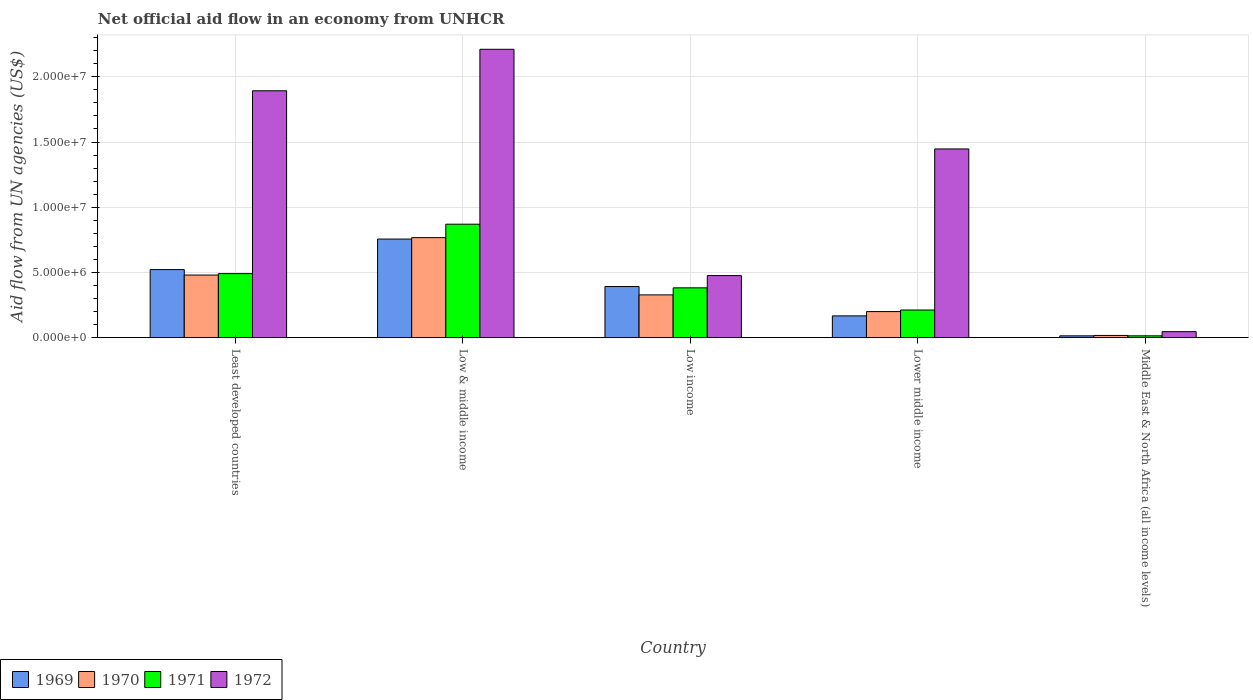How many different coloured bars are there?
Offer a terse response. 4. How many groups of bars are there?
Your answer should be compact. 5. Are the number of bars on each tick of the X-axis equal?
Keep it short and to the point. Yes. What is the label of the 4th group of bars from the left?
Your answer should be compact. Lower middle income. What is the net official aid flow in 1969 in Least developed countries?
Your answer should be very brief. 5.22e+06. Across all countries, what is the maximum net official aid flow in 1970?
Offer a terse response. 7.67e+06. Across all countries, what is the minimum net official aid flow in 1969?
Provide a succinct answer. 1.40e+05. In which country was the net official aid flow in 1972 minimum?
Your answer should be compact. Middle East & North Africa (all income levels). What is the total net official aid flow in 1970 in the graph?
Provide a short and direct response. 1.79e+07. What is the difference between the net official aid flow in 1972 in Least developed countries and that in Low & middle income?
Offer a terse response. -3.18e+06. What is the difference between the net official aid flow in 1972 in Low & middle income and the net official aid flow in 1970 in Low income?
Your answer should be compact. 1.88e+07. What is the average net official aid flow in 1972 per country?
Provide a short and direct response. 1.21e+07. What is the difference between the net official aid flow of/in 1972 and net official aid flow of/in 1971 in Low & middle income?
Make the answer very short. 1.34e+07. What is the ratio of the net official aid flow in 1971 in Least developed countries to that in Low income?
Your answer should be compact. 1.29. What is the difference between the highest and the second highest net official aid flow in 1971?
Your answer should be very brief. 4.88e+06. What is the difference between the highest and the lowest net official aid flow in 1972?
Offer a terse response. 2.16e+07. Is the sum of the net official aid flow in 1971 in Low income and Lower middle income greater than the maximum net official aid flow in 1969 across all countries?
Your answer should be very brief. No. Is it the case that in every country, the sum of the net official aid flow in 1970 and net official aid flow in 1971 is greater than the sum of net official aid flow in 1969 and net official aid flow in 1972?
Offer a very short reply. No. What does the 1st bar from the left in Least developed countries represents?
Offer a very short reply. 1969. How many bars are there?
Offer a very short reply. 20. Are all the bars in the graph horizontal?
Offer a very short reply. No. What is the difference between two consecutive major ticks on the Y-axis?
Give a very brief answer. 5.00e+06. Are the values on the major ticks of Y-axis written in scientific E-notation?
Your answer should be compact. Yes. Does the graph contain grids?
Your answer should be very brief. Yes. How are the legend labels stacked?
Make the answer very short. Horizontal. What is the title of the graph?
Make the answer very short. Net official aid flow in an economy from UNHCR. What is the label or title of the Y-axis?
Provide a short and direct response. Aid flow from UN agencies (US$). What is the Aid flow from UN agencies (US$) in 1969 in Least developed countries?
Provide a short and direct response. 5.22e+06. What is the Aid flow from UN agencies (US$) of 1970 in Least developed countries?
Provide a short and direct response. 4.80e+06. What is the Aid flow from UN agencies (US$) of 1971 in Least developed countries?
Provide a short and direct response. 4.91e+06. What is the Aid flow from UN agencies (US$) of 1972 in Least developed countries?
Provide a short and direct response. 1.89e+07. What is the Aid flow from UN agencies (US$) in 1969 in Low & middle income?
Offer a very short reply. 7.56e+06. What is the Aid flow from UN agencies (US$) of 1970 in Low & middle income?
Provide a short and direct response. 7.67e+06. What is the Aid flow from UN agencies (US$) in 1971 in Low & middle income?
Provide a short and direct response. 8.70e+06. What is the Aid flow from UN agencies (US$) in 1972 in Low & middle income?
Offer a very short reply. 2.21e+07. What is the Aid flow from UN agencies (US$) in 1969 in Low income?
Provide a short and direct response. 3.92e+06. What is the Aid flow from UN agencies (US$) of 1970 in Low income?
Ensure brevity in your answer.  3.28e+06. What is the Aid flow from UN agencies (US$) in 1971 in Low income?
Provide a short and direct response. 3.82e+06. What is the Aid flow from UN agencies (US$) of 1972 in Low income?
Provide a short and direct response. 4.76e+06. What is the Aid flow from UN agencies (US$) of 1969 in Lower middle income?
Give a very brief answer. 1.67e+06. What is the Aid flow from UN agencies (US$) of 1970 in Lower middle income?
Ensure brevity in your answer.  2.00e+06. What is the Aid flow from UN agencies (US$) of 1971 in Lower middle income?
Provide a short and direct response. 2.12e+06. What is the Aid flow from UN agencies (US$) of 1972 in Lower middle income?
Offer a terse response. 1.45e+07. What is the Aid flow from UN agencies (US$) in 1969 in Middle East & North Africa (all income levels)?
Your answer should be compact. 1.40e+05. Across all countries, what is the maximum Aid flow from UN agencies (US$) of 1969?
Your answer should be compact. 7.56e+06. Across all countries, what is the maximum Aid flow from UN agencies (US$) in 1970?
Your answer should be very brief. 7.67e+06. Across all countries, what is the maximum Aid flow from UN agencies (US$) in 1971?
Make the answer very short. 8.70e+06. Across all countries, what is the maximum Aid flow from UN agencies (US$) of 1972?
Your answer should be very brief. 2.21e+07. Across all countries, what is the minimum Aid flow from UN agencies (US$) in 1969?
Offer a very short reply. 1.40e+05. Across all countries, what is the minimum Aid flow from UN agencies (US$) in 1970?
Your answer should be very brief. 1.70e+05. Across all countries, what is the minimum Aid flow from UN agencies (US$) of 1972?
Offer a terse response. 4.60e+05. What is the total Aid flow from UN agencies (US$) in 1969 in the graph?
Ensure brevity in your answer.  1.85e+07. What is the total Aid flow from UN agencies (US$) in 1970 in the graph?
Offer a terse response. 1.79e+07. What is the total Aid flow from UN agencies (US$) of 1971 in the graph?
Your response must be concise. 1.97e+07. What is the total Aid flow from UN agencies (US$) in 1972 in the graph?
Keep it short and to the point. 6.07e+07. What is the difference between the Aid flow from UN agencies (US$) of 1969 in Least developed countries and that in Low & middle income?
Provide a succinct answer. -2.34e+06. What is the difference between the Aid flow from UN agencies (US$) in 1970 in Least developed countries and that in Low & middle income?
Your answer should be very brief. -2.87e+06. What is the difference between the Aid flow from UN agencies (US$) in 1971 in Least developed countries and that in Low & middle income?
Provide a short and direct response. -3.79e+06. What is the difference between the Aid flow from UN agencies (US$) in 1972 in Least developed countries and that in Low & middle income?
Your answer should be compact. -3.18e+06. What is the difference between the Aid flow from UN agencies (US$) in 1969 in Least developed countries and that in Low income?
Offer a very short reply. 1.30e+06. What is the difference between the Aid flow from UN agencies (US$) of 1970 in Least developed countries and that in Low income?
Keep it short and to the point. 1.52e+06. What is the difference between the Aid flow from UN agencies (US$) in 1971 in Least developed countries and that in Low income?
Make the answer very short. 1.09e+06. What is the difference between the Aid flow from UN agencies (US$) of 1972 in Least developed countries and that in Low income?
Provide a succinct answer. 1.42e+07. What is the difference between the Aid flow from UN agencies (US$) in 1969 in Least developed countries and that in Lower middle income?
Your answer should be compact. 3.55e+06. What is the difference between the Aid flow from UN agencies (US$) of 1970 in Least developed countries and that in Lower middle income?
Keep it short and to the point. 2.80e+06. What is the difference between the Aid flow from UN agencies (US$) in 1971 in Least developed countries and that in Lower middle income?
Keep it short and to the point. 2.79e+06. What is the difference between the Aid flow from UN agencies (US$) of 1972 in Least developed countries and that in Lower middle income?
Provide a short and direct response. 4.46e+06. What is the difference between the Aid flow from UN agencies (US$) of 1969 in Least developed countries and that in Middle East & North Africa (all income levels)?
Your answer should be compact. 5.08e+06. What is the difference between the Aid flow from UN agencies (US$) in 1970 in Least developed countries and that in Middle East & North Africa (all income levels)?
Make the answer very short. 4.63e+06. What is the difference between the Aid flow from UN agencies (US$) in 1971 in Least developed countries and that in Middle East & North Africa (all income levels)?
Provide a short and direct response. 4.77e+06. What is the difference between the Aid flow from UN agencies (US$) in 1972 in Least developed countries and that in Middle East & North Africa (all income levels)?
Keep it short and to the point. 1.85e+07. What is the difference between the Aid flow from UN agencies (US$) of 1969 in Low & middle income and that in Low income?
Offer a terse response. 3.64e+06. What is the difference between the Aid flow from UN agencies (US$) in 1970 in Low & middle income and that in Low income?
Make the answer very short. 4.39e+06. What is the difference between the Aid flow from UN agencies (US$) of 1971 in Low & middle income and that in Low income?
Offer a very short reply. 4.88e+06. What is the difference between the Aid flow from UN agencies (US$) of 1972 in Low & middle income and that in Low income?
Make the answer very short. 1.74e+07. What is the difference between the Aid flow from UN agencies (US$) in 1969 in Low & middle income and that in Lower middle income?
Provide a succinct answer. 5.89e+06. What is the difference between the Aid flow from UN agencies (US$) of 1970 in Low & middle income and that in Lower middle income?
Provide a succinct answer. 5.67e+06. What is the difference between the Aid flow from UN agencies (US$) in 1971 in Low & middle income and that in Lower middle income?
Provide a short and direct response. 6.58e+06. What is the difference between the Aid flow from UN agencies (US$) of 1972 in Low & middle income and that in Lower middle income?
Your answer should be compact. 7.64e+06. What is the difference between the Aid flow from UN agencies (US$) of 1969 in Low & middle income and that in Middle East & North Africa (all income levels)?
Your response must be concise. 7.42e+06. What is the difference between the Aid flow from UN agencies (US$) in 1970 in Low & middle income and that in Middle East & North Africa (all income levels)?
Offer a terse response. 7.50e+06. What is the difference between the Aid flow from UN agencies (US$) in 1971 in Low & middle income and that in Middle East & North Africa (all income levels)?
Give a very brief answer. 8.56e+06. What is the difference between the Aid flow from UN agencies (US$) in 1972 in Low & middle income and that in Middle East & North Africa (all income levels)?
Offer a very short reply. 2.16e+07. What is the difference between the Aid flow from UN agencies (US$) in 1969 in Low income and that in Lower middle income?
Provide a short and direct response. 2.25e+06. What is the difference between the Aid flow from UN agencies (US$) in 1970 in Low income and that in Lower middle income?
Ensure brevity in your answer.  1.28e+06. What is the difference between the Aid flow from UN agencies (US$) of 1971 in Low income and that in Lower middle income?
Provide a short and direct response. 1.70e+06. What is the difference between the Aid flow from UN agencies (US$) of 1972 in Low income and that in Lower middle income?
Your answer should be compact. -9.71e+06. What is the difference between the Aid flow from UN agencies (US$) of 1969 in Low income and that in Middle East & North Africa (all income levels)?
Provide a short and direct response. 3.78e+06. What is the difference between the Aid flow from UN agencies (US$) in 1970 in Low income and that in Middle East & North Africa (all income levels)?
Offer a terse response. 3.11e+06. What is the difference between the Aid flow from UN agencies (US$) in 1971 in Low income and that in Middle East & North Africa (all income levels)?
Keep it short and to the point. 3.68e+06. What is the difference between the Aid flow from UN agencies (US$) in 1972 in Low income and that in Middle East & North Africa (all income levels)?
Ensure brevity in your answer.  4.30e+06. What is the difference between the Aid flow from UN agencies (US$) of 1969 in Lower middle income and that in Middle East & North Africa (all income levels)?
Your answer should be very brief. 1.53e+06. What is the difference between the Aid flow from UN agencies (US$) in 1970 in Lower middle income and that in Middle East & North Africa (all income levels)?
Provide a short and direct response. 1.83e+06. What is the difference between the Aid flow from UN agencies (US$) of 1971 in Lower middle income and that in Middle East & North Africa (all income levels)?
Provide a short and direct response. 1.98e+06. What is the difference between the Aid flow from UN agencies (US$) in 1972 in Lower middle income and that in Middle East & North Africa (all income levels)?
Your answer should be very brief. 1.40e+07. What is the difference between the Aid flow from UN agencies (US$) of 1969 in Least developed countries and the Aid flow from UN agencies (US$) of 1970 in Low & middle income?
Ensure brevity in your answer.  -2.45e+06. What is the difference between the Aid flow from UN agencies (US$) in 1969 in Least developed countries and the Aid flow from UN agencies (US$) in 1971 in Low & middle income?
Ensure brevity in your answer.  -3.48e+06. What is the difference between the Aid flow from UN agencies (US$) in 1969 in Least developed countries and the Aid flow from UN agencies (US$) in 1972 in Low & middle income?
Provide a succinct answer. -1.69e+07. What is the difference between the Aid flow from UN agencies (US$) of 1970 in Least developed countries and the Aid flow from UN agencies (US$) of 1971 in Low & middle income?
Your answer should be very brief. -3.90e+06. What is the difference between the Aid flow from UN agencies (US$) of 1970 in Least developed countries and the Aid flow from UN agencies (US$) of 1972 in Low & middle income?
Ensure brevity in your answer.  -1.73e+07. What is the difference between the Aid flow from UN agencies (US$) of 1971 in Least developed countries and the Aid flow from UN agencies (US$) of 1972 in Low & middle income?
Your answer should be compact. -1.72e+07. What is the difference between the Aid flow from UN agencies (US$) in 1969 in Least developed countries and the Aid flow from UN agencies (US$) in 1970 in Low income?
Provide a short and direct response. 1.94e+06. What is the difference between the Aid flow from UN agencies (US$) in 1969 in Least developed countries and the Aid flow from UN agencies (US$) in 1971 in Low income?
Offer a very short reply. 1.40e+06. What is the difference between the Aid flow from UN agencies (US$) of 1970 in Least developed countries and the Aid flow from UN agencies (US$) of 1971 in Low income?
Give a very brief answer. 9.80e+05. What is the difference between the Aid flow from UN agencies (US$) of 1970 in Least developed countries and the Aid flow from UN agencies (US$) of 1972 in Low income?
Your answer should be very brief. 4.00e+04. What is the difference between the Aid flow from UN agencies (US$) of 1971 in Least developed countries and the Aid flow from UN agencies (US$) of 1972 in Low income?
Give a very brief answer. 1.50e+05. What is the difference between the Aid flow from UN agencies (US$) of 1969 in Least developed countries and the Aid flow from UN agencies (US$) of 1970 in Lower middle income?
Your answer should be compact. 3.22e+06. What is the difference between the Aid flow from UN agencies (US$) of 1969 in Least developed countries and the Aid flow from UN agencies (US$) of 1971 in Lower middle income?
Provide a short and direct response. 3.10e+06. What is the difference between the Aid flow from UN agencies (US$) of 1969 in Least developed countries and the Aid flow from UN agencies (US$) of 1972 in Lower middle income?
Provide a short and direct response. -9.25e+06. What is the difference between the Aid flow from UN agencies (US$) in 1970 in Least developed countries and the Aid flow from UN agencies (US$) in 1971 in Lower middle income?
Your answer should be very brief. 2.68e+06. What is the difference between the Aid flow from UN agencies (US$) of 1970 in Least developed countries and the Aid flow from UN agencies (US$) of 1972 in Lower middle income?
Your answer should be compact. -9.67e+06. What is the difference between the Aid flow from UN agencies (US$) in 1971 in Least developed countries and the Aid flow from UN agencies (US$) in 1972 in Lower middle income?
Your answer should be very brief. -9.56e+06. What is the difference between the Aid flow from UN agencies (US$) of 1969 in Least developed countries and the Aid flow from UN agencies (US$) of 1970 in Middle East & North Africa (all income levels)?
Offer a terse response. 5.05e+06. What is the difference between the Aid flow from UN agencies (US$) of 1969 in Least developed countries and the Aid flow from UN agencies (US$) of 1971 in Middle East & North Africa (all income levels)?
Keep it short and to the point. 5.08e+06. What is the difference between the Aid flow from UN agencies (US$) of 1969 in Least developed countries and the Aid flow from UN agencies (US$) of 1972 in Middle East & North Africa (all income levels)?
Your response must be concise. 4.76e+06. What is the difference between the Aid flow from UN agencies (US$) of 1970 in Least developed countries and the Aid flow from UN agencies (US$) of 1971 in Middle East & North Africa (all income levels)?
Keep it short and to the point. 4.66e+06. What is the difference between the Aid flow from UN agencies (US$) in 1970 in Least developed countries and the Aid flow from UN agencies (US$) in 1972 in Middle East & North Africa (all income levels)?
Your response must be concise. 4.34e+06. What is the difference between the Aid flow from UN agencies (US$) in 1971 in Least developed countries and the Aid flow from UN agencies (US$) in 1972 in Middle East & North Africa (all income levels)?
Your answer should be very brief. 4.45e+06. What is the difference between the Aid flow from UN agencies (US$) in 1969 in Low & middle income and the Aid flow from UN agencies (US$) in 1970 in Low income?
Your answer should be very brief. 4.28e+06. What is the difference between the Aid flow from UN agencies (US$) in 1969 in Low & middle income and the Aid flow from UN agencies (US$) in 1971 in Low income?
Keep it short and to the point. 3.74e+06. What is the difference between the Aid flow from UN agencies (US$) in 1969 in Low & middle income and the Aid flow from UN agencies (US$) in 1972 in Low income?
Keep it short and to the point. 2.80e+06. What is the difference between the Aid flow from UN agencies (US$) of 1970 in Low & middle income and the Aid flow from UN agencies (US$) of 1971 in Low income?
Give a very brief answer. 3.85e+06. What is the difference between the Aid flow from UN agencies (US$) of 1970 in Low & middle income and the Aid flow from UN agencies (US$) of 1972 in Low income?
Your answer should be compact. 2.91e+06. What is the difference between the Aid flow from UN agencies (US$) of 1971 in Low & middle income and the Aid flow from UN agencies (US$) of 1972 in Low income?
Ensure brevity in your answer.  3.94e+06. What is the difference between the Aid flow from UN agencies (US$) of 1969 in Low & middle income and the Aid flow from UN agencies (US$) of 1970 in Lower middle income?
Your response must be concise. 5.56e+06. What is the difference between the Aid flow from UN agencies (US$) in 1969 in Low & middle income and the Aid flow from UN agencies (US$) in 1971 in Lower middle income?
Your response must be concise. 5.44e+06. What is the difference between the Aid flow from UN agencies (US$) in 1969 in Low & middle income and the Aid flow from UN agencies (US$) in 1972 in Lower middle income?
Your answer should be very brief. -6.91e+06. What is the difference between the Aid flow from UN agencies (US$) of 1970 in Low & middle income and the Aid flow from UN agencies (US$) of 1971 in Lower middle income?
Your answer should be very brief. 5.55e+06. What is the difference between the Aid flow from UN agencies (US$) of 1970 in Low & middle income and the Aid flow from UN agencies (US$) of 1972 in Lower middle income?
Make the answer very short. -6.80e+06. What is the difference between the Aid flow from UN agencies (US$) in 1971 in Low & middle income and the Aid flow from UN agencies (US$) in 1972 in Lower middle income?
Provide a succinct answer. -5.77e+06. What is the difference between the Aid flow from UN agencies (US$) in 1969 in Low & middle income and the Aid flow from UN agencies (US$) in 1970 in Middle East & North Africa (all income levels)?
Keep it short and to the point. 7.39e+06. What is the difference between the Aid flow from UN agencies (US$) of 1969 in Low & middle income and the Aid flow from UN agencies (US$) of 1971 in Middle East & North Africa (all income levels)?
Offer a very short reply. 7.42e+06. What is the difference between the Aid flow from UN agencies (US$) in 1969 in Low & middle income and the Aid flow from UN agencies (US$) in 1972 in Middle East & North Africa (all income levels)?
Your answer should be compact. 7.10e+06. What is the difference between the Aid flow from UN agencies (US$) in 1970 in Low & middle income and the Aid flow from UN agencies (US$) in 1971 in Middle East & North Africa (all income levels)?
Keep it short and to the point. 7.53e+06. What is the difference between the Aid flow from UN agencies (US$) of 1970 in Low & middle income and the Aid flow from UN agencies (US$) of 1972 in Middle East & North Africa (all income levels)?
Provide a succinct answer. 7.21e+06. What is the difference between the Aid flow from UN agencies (US$) of 1971 in Low & middle income and the Aid flow from UN agencies (US$) of 1972 in Middle East & North Africa (all income levels)?
Your answer should be compact. 8.24e+06. What is the difference between the Aid flow from UN agencies (US$) of 1969 in Low income and the Aid flow from UN agencies (US$) of 1970 in Lower middle income?
Keep it short and to the point. 1.92e+06. What is the difference between the Aid flow from UN agencies (US$) in 1969 in Low income and the Aid flow from UN agencies (US$) in 1971 in Lower middle income?
Your answer should be very brief. 1.80e+06. What is the difference between the Aid flow from UN agencies (US$) in 1969 in Low income and the Aid flow from UN agencies (US$) in 1972 in Lower middle income?
Make the answer very short. -1.06e+07. What is the difference between the Aid flow from UN agencies (US$) in 1970 in Low income and the Aid flow from UN agencies (US$) in 1971 in Lower middle income?
Make the answer very short. 1.16e+06. What is the difference between the Aid flow from UN agencies (US$) in 1970 in Low income and the Aid flow from UN agencies (US$) in 1972 in Lower middle income?
Provide a succinct answer. -1.12e+07. What is the difference between the Aid flow from UN agencies (US$) of 1971 in Low income and the Aid flow from UN agencies (US$) of 1972 in Lower middle income?
Provide a short and direct response. -1.06e+07. What is the difference between the Aid flow from UN agencies (US$) in 1969 in Low income and the Aid flow from UN agencies (US$) in 1970 in Middle East & North Africa (all income levels)?
Your answer should be very brief. 3.75e+06. What is the difference between the Aid flow from UN agencies (US$) of 1969 in Low income and the Aid flow from UN agencies (US$) of 1971 in Middle East & North Africa (all income levels)?
Your answer should be compact. 3.78e+06. What is the difference between the Aid flow from UN agencies (US$) in 1969 in Low income and the Aid flow from UN agencies (US$) in 1972 in Middle East & North Africa (all income levels)?
Your answer should be compact. 3.46e+06. What is the difference between the Aid flow from UN agencies (US$) in 1970 in Low income and the Aid flow from UN agencies (US$) in 1971 in Middle East & North Africa (all income levels)?
Give a very brief answer. 3.14e+06. What is the difference between the Aid flow from UN agencies (US$) of 1970 in Low income and the Aid flow from UN agencies (US$) of 1972 in Middle East & North Africa (all income levels)?
Make the answer very short. 2.82e+06. What is the difference between the Aid flow from UN agencies (US$) of 1971 in Low income and the Aid flow from UN agencies (US$) of 1972 in Middle East & North Africa (all income levels)?
Your answer should be compact. 3.36e+06. What is the difference between the Aid flow from UN agencies (US$) in 1969 in Lower middle income and the Aid flow from UN agencies (US$) in 1970 in Middle East & North Africa (all income levels)?
Make the answer very short. 1.50e+06. What is the difference between the Aid flow from UN agencies (US$) in 1969 in Lower middle income and the Aid flow from UN agencies (US$) in 1971 in Middle East & North Africa (all income levels)?
Your response must be concise. 1.53e+06. What is the difference between the Aid flow from UN agencies (US$) in 1969 in Lower middle income and the Aid flow from UN agencies (US$) in 1972 in Middle East & North Africa (all income levels)?
Your answer should be very brief. 1.21e+06. What is the difference between the Aid flow from UN agencies (US$) in 1970 in Lower middle income and the Aid flow from UN agencies (US$) in 1971 in Middle East & North Africa (all income levels)?
Give a very brief answer. 1.86e+06. What is the difference between the Aid flow from UN agencies (US$) in 1970 in Lower middle income and the Aid flow from UN agencies (US$) in 1972 in Middle East & North Africa (all income levels)?
Offer a terse response. 1.54e+06. What is the difference between the Aid flow from UN agencies (US$) in 1971 in Lower middle income and the Aid flow from UN agencies (US$) in 1972 in Middle East & North Africa (all income levels)?
Make the answer very short. 1.66e+06. What is the average Aid flow from UN agencies (US$) in 1969 per country?
Provide a short and direct response. 3.70e+06. What is the average Aid flow from UN agencies (US$) in 1970 per country?
Provide a succinct answer. 3.58e+06. What is the average Aid flow from UN agencies (US$) of 1971 per country?
Make the answer very short. 3.94e+06. What is the average Aid flow from UN agencies (US$) in 1972 per country?
Your response must be concise. 1.21e+07. What is the difference between the Aid flow from UN agencies (US$) of 1969 and Aid flow from UN agencies (US$) of 1971 in Least developed countries?
Keep it short and to the point. 3.10e+05. What is the difference between the Aid flow from UN agencies (US$) in 1969 and Aid flow from UN agencies (US$) in 1972 in Least developed countries?
Provide a short and direct response. -1.37e+07. What is the difference between the Aid flow from UN agencies (US$) in 1970 and Aid flow from UN agencies (US$) in 1971 in Least developed countries?
Your answer should be compact. -1.10e+05. What is the difference between the Aid flow from UN agencies (US$) of 1970 and Aid flow from UN agencies (US$) of 1972 in Least developed countries?
Offer a terse response. -1.41e+07. What is the difference between the Aid flow from UN agencies (US$) of 1971 and Aid flow from UN agencies (US$) of 1972 in Least developed countries?
Provide a short and direct response. -1.40e+07. What is the difference between the Aid flow from UN agencies (US$) of 1969 and Aid flow from UN agencies (US$) of 1971 in Low & middle income?
Offer a terse response. -1.14e+06. What is the difference between the Aid flow from UN agencies (US$) of 1969 and Aid flow from UN agencies (US$) of 1972 in Low & middle income?
Make the answer very short. -1.46e+07. What is the difference between the Aid flow from UN agencies (US$) in 1970 and Aid flow from UN agencies (US$) in 1971 in Low & middle income?
Your answer should be very brief. -1.03e+06. What is the difference between the Aid flow from UN agencies (US$) of 1970 and Aid flow from UN agencies (US$) of 1972 in Low & middle income?
Offer a very short reply. -1.44e+07. What is the difference between the Aid flow from UN agencies (US$) of 1971 and Aid flow from UN agencies (US$) of 1972 in Low & middle income?
Provide a short and direct response. -1.34e+07. What is the difference between the Aid flow from UN agencies (US$) in 1969 and Aid flow from UN agencies (US$) in 1970 in Low income?
Your answer should be very brief. 6.40e+05. What is the difference between the Aid flow from UN agencies (US$) of 1969 and Aid flow from UN agencies (US$) of 1971 in Low income?
Keep it short and to the point. 1.00e+05. What is the difference between the Aid flow from UN agencies (US$) of 1969 and Aid flow from UN agencies (US$) of 1972 in Low income?
Your answer should be very brief. -8.40e+05. What is the difference between the Aid flow from UN agencies (US$) of 1970 and Aid flow from UN agencies (US$) of 1971 in Low income?
Give a very brief answer. -5.40e+05. What is the difference between the Aid flow from UN agencies (US$) of 1970 and Aid flow from UN agencies (US$) of 1972 in Low income?
Keep it short and to the point. -1.48e+06. What is the difference between the Aid flow from UN agencies (US$) of 1971 and Aid flow from UN agencies (US$) of 1972 in Low income?
Keep it short and to the point. -9.40e+05. What is the difference between the Aid flow from UN agencies (US$) in 1969 and Aid flow from UN agencies (US$) in 1970 in Lower middle income?
Your answer should be compact. -3.30e+05. What is the difference between the Aid flow from UN agencies (US$) of 1969 and Aid flow from UN agencies (US$) of 1971 in Lower middle income?
Your response must be concise. -4.50e+05. What is the difference between the Aid flow from UN agencies (US$) of 1969 and Aid flow from UN agencies (US$) of 1972 in Lower middle income?
Make the answer very short. -1.28e+07. What is the difference between the Aid flow from UN agencies (US$) of 1970 and Aid flow from UN agencies (US$) of 1972 in Lower middle income?
Your answer should be compact. -1.25e+07. What is the difference between the Aid flow from UN agencies (US$) of 1971 and Aid flow from UN agencies (US$) of 1972 in Lower middle income?
Your answer should be very brief. -1.24e+07. What is the difference between the Aid flow from UN agencies (US$) in 1969 and Aid flow from UN agencies (US$) in 1972 in Middle East & North Africa (all income levels)?
Keep it short and to the point. -3.20e+05. What is the difference between the Aid flow from UN agencies (US$) in 1971 and Aid flow from UN agencies (US$) in 1972 in Middle East & North Africa (all income levels)?
Your answer should be compact. -3.20e+05. What is the ratio of the Aid flow from UN agencies (US$) in 1969 in Least developed countries to that in Low & middle income?
Offer a terse response. 0.69. What is the ratio of the Aid flow from UN agencies (US$) in 1970 in Least developed countries to that in Low & middle income?
Give a very brief answer. 0.63. What is the ratio of the Aid flow from UN agencies (US$) in 1971 in Least developed countries to that in Low & middle income?
Offer a very short reply. 0.56. What is the ratio of the Aid flow from UN agencies (US$) of 1972 in Least developed countries to that in Low & middle income?
Provide a short and direct response. 0.86. What is the ratio of the Aid flow from UN agencies (US$) in 1969 in Least developed countries to that in Low income?
Give a very brief answer. 1.33. What is the ratio of the Aid flow from UN agencies (US$) of 1970 in Least developed countries to that in Low income?
Ensure brevity in your answer.  1.46. What is the ratio of the Aid flow from UN agencies (US$) of 1971 in Least developed countries to that in Low income?
Your response must be concise. 1.29. What is the ratio of the Aid flow from UN agencies (US$) of 1972 in Least developed countries to that in Low income?
Your answer should be compact. 3.98. What is the ratio of the Aid flow from UN agencies (US$) of 1969 in Least developed countries to that in Lower middle income?
Keep it short and to the point. 3.13. What is the ratio of the Aid flow from UN agencies (US$) in 1970 in Least developed countries to that in Lower middle income?
Give a very brief answer. 2.4. What is the ratio of the Aid flow from UN agencies (US$) in 1971 in Least developed countries to that in Lower middle income?
Offer a very short reply. 2.32. What is the ratio of the Aid flow from UN agencies (US$) in 1972 in Least developed countries to that in Lower middle income?
Your answer should be compact. 1.31. What is the ratio of the Aid flow from UN agencies (US$) of 1969 in Least developed countries to that in Middle East & North Africa (all income levels)?
Make the answer very short. 37.29. What is the ratio of the Aid flow from UN agencies (US$) in 1970 in Least developed countries to that in Middle East & North Africa (all income levels)?
Provide a short and direct response. 28.24. What is the ratio of the Aid flow from UN agencies (US$) of 1971 in Least developed countries to that in Middle East & North Africa (all income levels)?
Your response must be concise. 35.07. What is the ratio of the Aid flow from UN agencies (US$) of 1972 in Least developed countries to that in Middle East & North Africa (all income levels)?
Your answer should be very brief. 41.15. What is the ratio of the Aid flow from UN agencies (US$) in 1969 in Low & middle income to that in Low income?
Your response must be concise. 1.93. What is the ratio of the Aid flow from UN agencies (US$) in 1970 in Low & middle income to that in Low income?
Provide a short and direct response. 2.34. What is the ratio of the Aid flow from UN agencies (US$) of 1971 in Low & middle income to that in Low income?
Keep it short and to the point. 2.28. What is the ratio of the Aid flow from UN agencies (US$) in 1972 in Low & middle income to that in Low income?
Your answer should be compact. 4.64. What is the ratio of the Aid flow from UN agencies (US$) in 1969 in Low & middle income to that in Lower middle income?
Ensure brevity in your answer.  4.53. What is the ratio of the Aid flow from UN agencies (US$) in 1970 in Low & middle income to that in Lower middle income?
Your response must be concise. 3.83. What is the ratio of the Aid flow from UN agencies (US$) of 1971 in Low & middle income to that in Lower middle income?
Ensure brevity in your answer.  4.1. What is the ratio of the Aid flow from UN agencies (US$) of 1972 in Low & middle income to that in Lower middle income?
Offer a very short reply. 1.53. What is the ratio of the Aid flow from UN agencies (US$) of 1969 in Low & middle income to that in Middle East & North Africa (all income levels)?
Your answer should be very brief. 54. What is the ratio of the Aid flow from UN agencies (US$) in 1970 in Low & middle income to that in Middle East & North Africa (all income levels)?
Offer a very short reply. 45.12. What is the ratio of the Aid flow from UN agencies (US$) of 1971 in Low & middle income to that in Middle East & North Africa (all income levels)?
Offer a terse response. 62.14. What is the ratio of the Aid flow from UN agencies (US$) of 1972 in Low & middle income to that in Middle East & North Africa (all income levels)?
Ensure brevity in your answer.  48.07. What is the ratio of the Aid flow from UN agencies (US$) in 1969 in Low income to that in Lower middle income?
Keep it short and to the point. 2.35. What is the ratio of the Aid flow from UN agencies (US$) in 1970 in Low income to that in Lower middle income?
Give a very brief answer. 1.64. What is the ratio of the Aid flow from UN agencies (US$) of 1971 in Low income to that in Lower middle income?
Make the answer very short. 1.8. What is the ratio of the Aid flow from UN agencies (US$) in 1972 in Low income to that in Lower middle income?
Offer a terse response. 0.33. What is the ratio of the Aid flow from UN agencies (US$) in 1969 in Low income to that in Middle East & North Africa (all income levels)?
Offer a very short reply. 28. What is the ratio of the Aid flow from UN agencies (US$) of 1970 in Low income to that in Middle East & North Africa (all income levels)?
Your answer should be compact. 19.29. What is the ratio of the Aid flow from UN agencies (US$) in 1971 in Low income to that in Middle East & North Africa (all income levels)?
Offer a terse response. 27.29. What is the ratio of the Aid flow from UN agencies (US$) of 1972 in Low income to that in Middle East & North Africa (all income levels)?
Keep it short and to the point. 10.35. What is the ratio of the Aid flow from UN agencies (US$) in 1969 in Lower middle income to that in Middle East & North Africa (all income levels)?
Make the answer very short. 11.93. What is the ratio of the Aid flow from UN agencies (US$) in 1970 in Lower middle income to that in Middle East & North Africa (all income levels)?
Offer a terse response. 11.76. What is the ratio of the Aid flow from UN agencies (US$) of 1971 in Lower middle income to that in Middle East & North Africa (all income levels)?
Your answer should be very brief. 15.14. What is the ratio of the Aid flow from UN agencies (US$) of 1972 in Lower middle income to that in Middle East & North Africa (all income levels)?
Offer a very short reply. 31.46. What is the difference between the highest and the second highest Aid flow from UN agencies (US$) of 1969?
Offer a very short reply. 2.34e+06. What is the difference between the highest and the second highest Aid flow from UN agencies (US$) of 1970?
Provide a short and direct response. 2.87e+06. What is the difference between the highest and the second highest Aid flow from UN agencies (US$) of 1971?
Make the answer very short. 3.79e+06. What is the difference between the highest and the second highest Aid flow from UN agencies (US$) in 1972?
Ensure brevity in your answer.  3.18e+06. What is the difference between the highest and the lowest Aid flow from UN agencies (US$) in 1969?
Your answer should be very brief. 7.42e+06. What is the difference between the highest and the lowest Aid flow from UN agencies (US$) of 1970?
Your answer should be compact. 7.50e+06. What is the difference between the highest and the lowest Aid flow from UN agencies (US$) of 1971?
Make the answer very short. 8.56e+06. What is the difference between the highest and the lowest Aid flow from UN agencies (US$) in 1972?
Keep it short and to the point. 2.16e+07. 